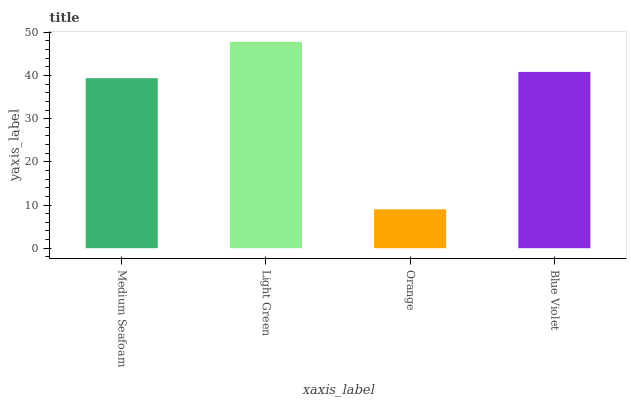Is Orange the minimum?
Answer yes or no. Yes. Is Light Green the maximum?
Answer yes or no. Yes. Is Light Green the minimum?
Answer yes or no. No. Is Orange the maximum?
Answer yes or no. No. Is Light Green greater than Orange?
Answer yes or no. Yes. Is Orange less than Light Green?
Answer yes or no. Yes. Is Orange greater than Light Green?
Answer yes or no. No. Is Light Green less than Orange?
Answer yes or no. No. Is Blue Violet the high median?
Answer yes or no. Yes. Is Medium Seafoam the low median?
Answer yes or no. Yes. Is Medium Seafoam the high median?
Answer yes or no. No. Is Light Green the low median?
Answer yes or no. No. 